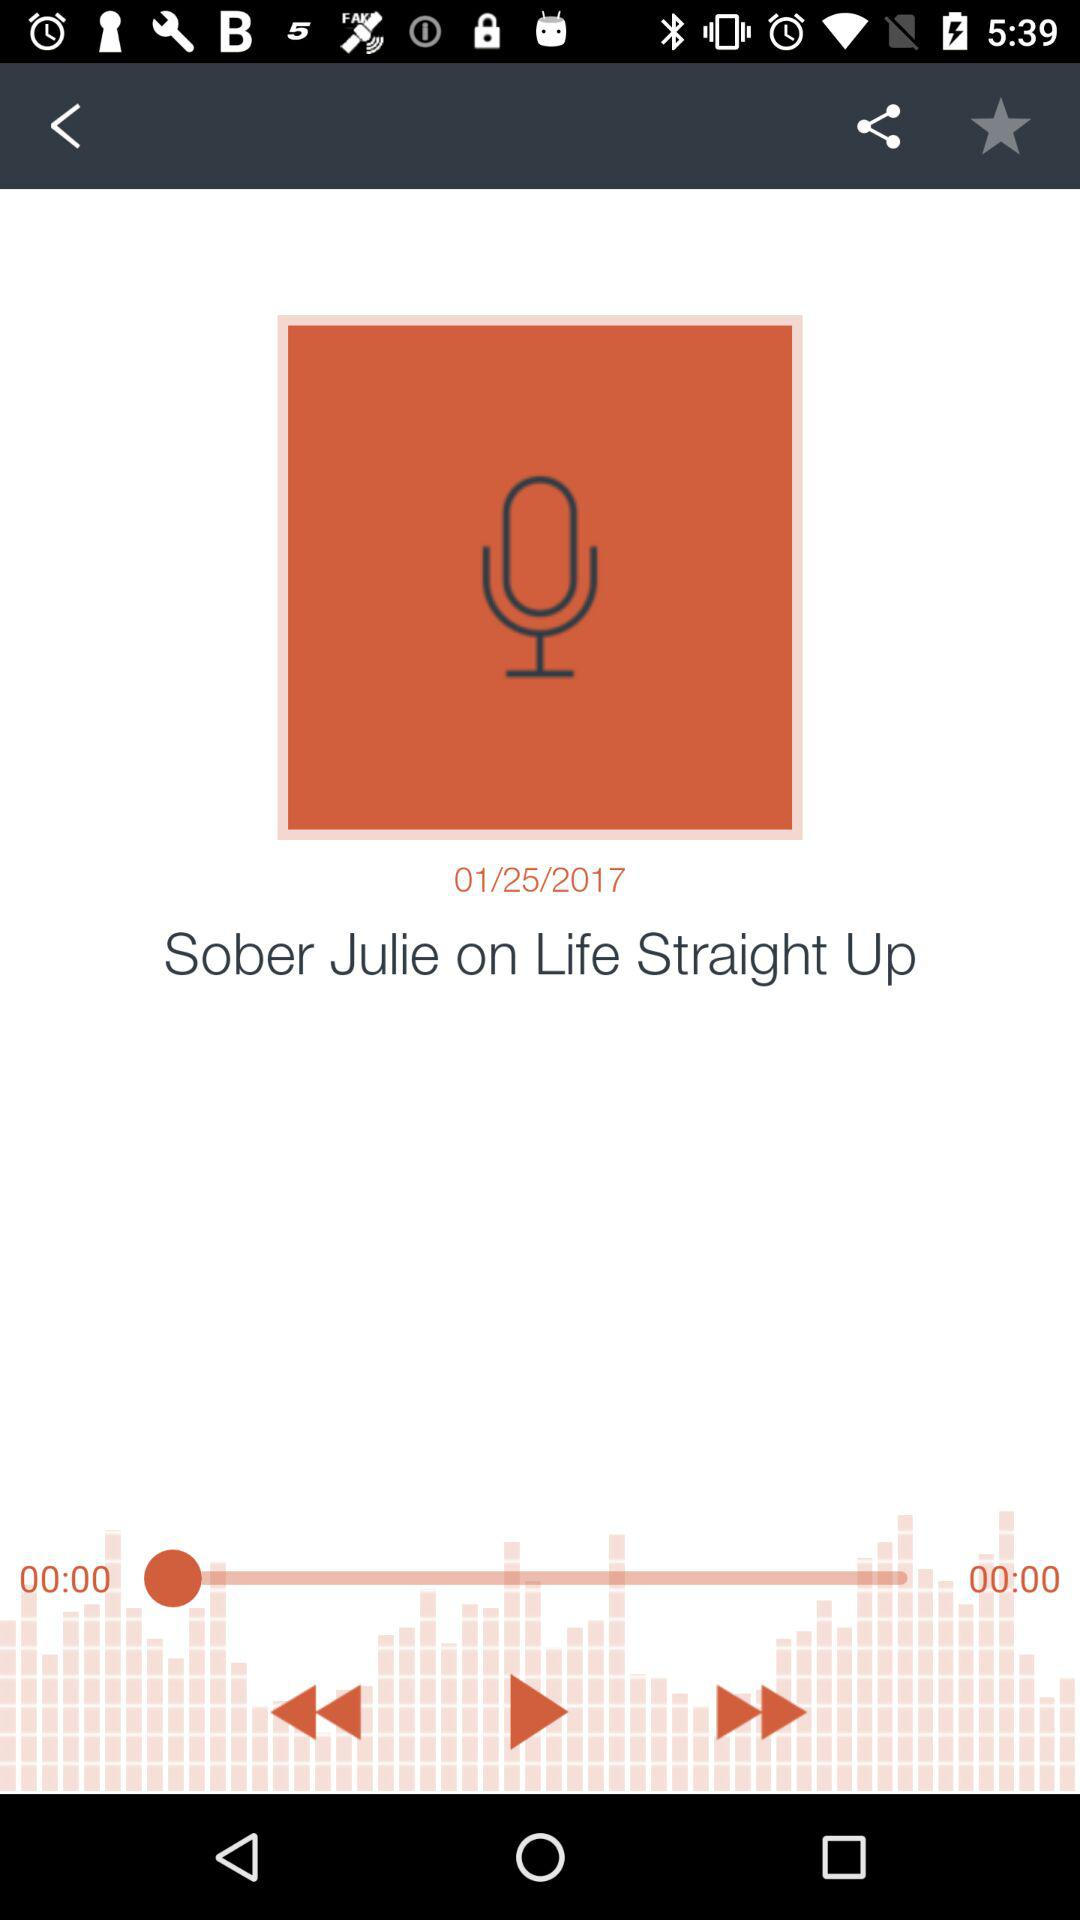What is the date shown on the screen? The date shown on the screen is January 25, 2017. 